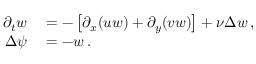<formula> <loc_0><loc_0><loc_500><loc_500>\begin{array} { r l } { \partial _ { t } w } & = - \left [ \partial _ { x } ( u w ) + \partial _ { y } ( v w ) \right ] + \nu \Delta w \, , } \\ { \Delta \psi } & = - w \, . } \end{array}</formula> 